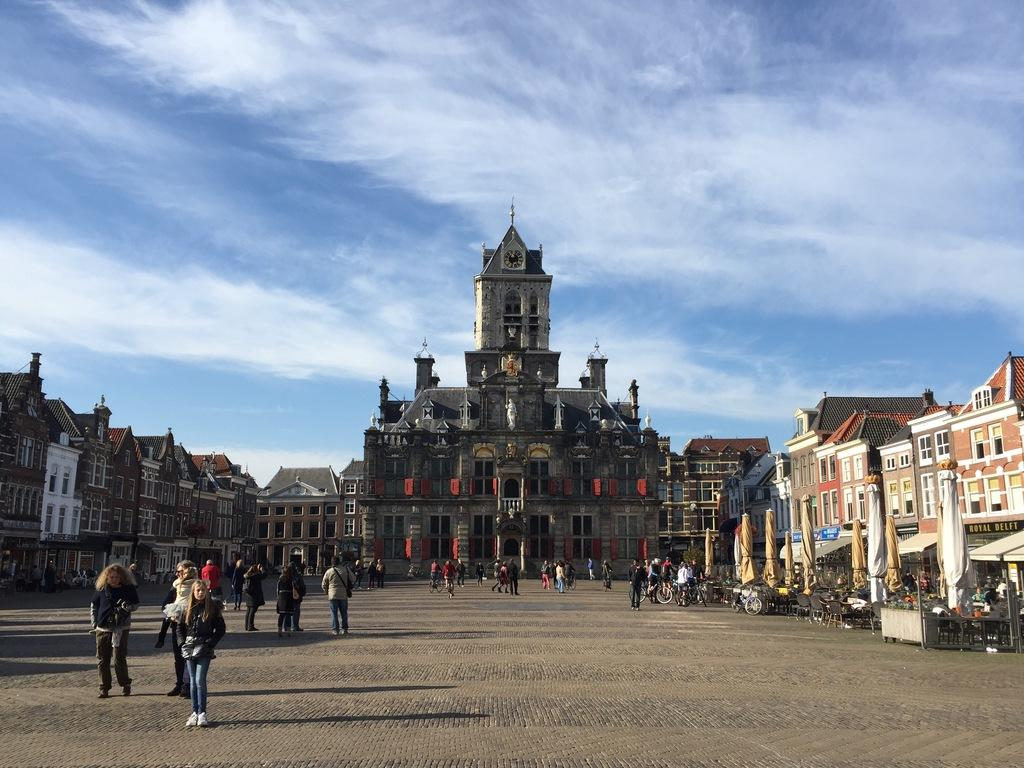What are the people in the image doing? There are people walking on the road in the image. What can be seen on either side of the road? There are buildings on either side of the road. What is the main structure in the middle of the image? There is a palace in the middle of the image. What is visible in the background of the image? The sky is visible in the image, and clouds are present in the sky. Can you see the dock where the mint leaves are being dried in the image? There is no dock or mint leaves present in the image. What color is the tongue of the person walking on the road in the image? There is no visible tongue of any person in the image. 